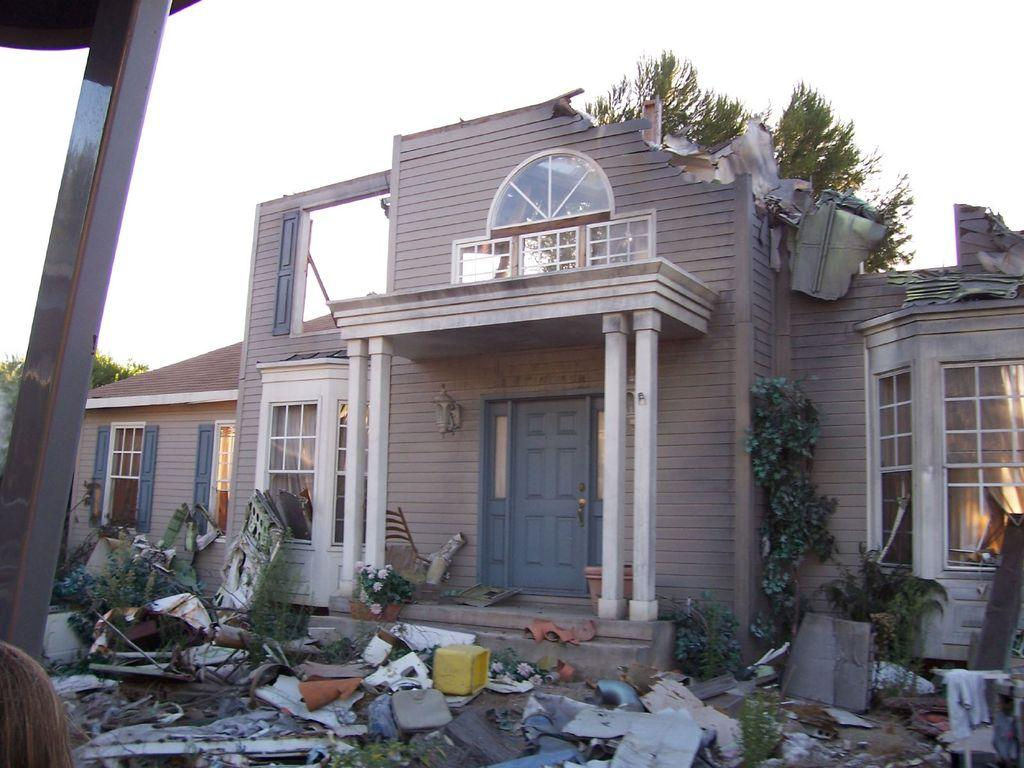What is the main subject of the image? The main subject of the image is a collapsed building. What can be seen in front of the collapsed building? There is garbage in front of the collapsed building. What is visible behind the collapsed building? There are trees visible behind the collapsed building. Can you see a crib near the collapsed building in the image? There is no crib present in the image. 